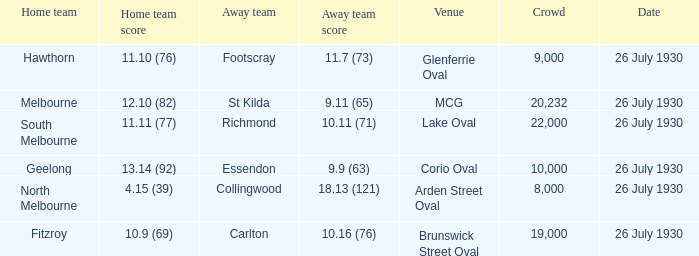Where did Geelong play a home game? Corio Oval. 